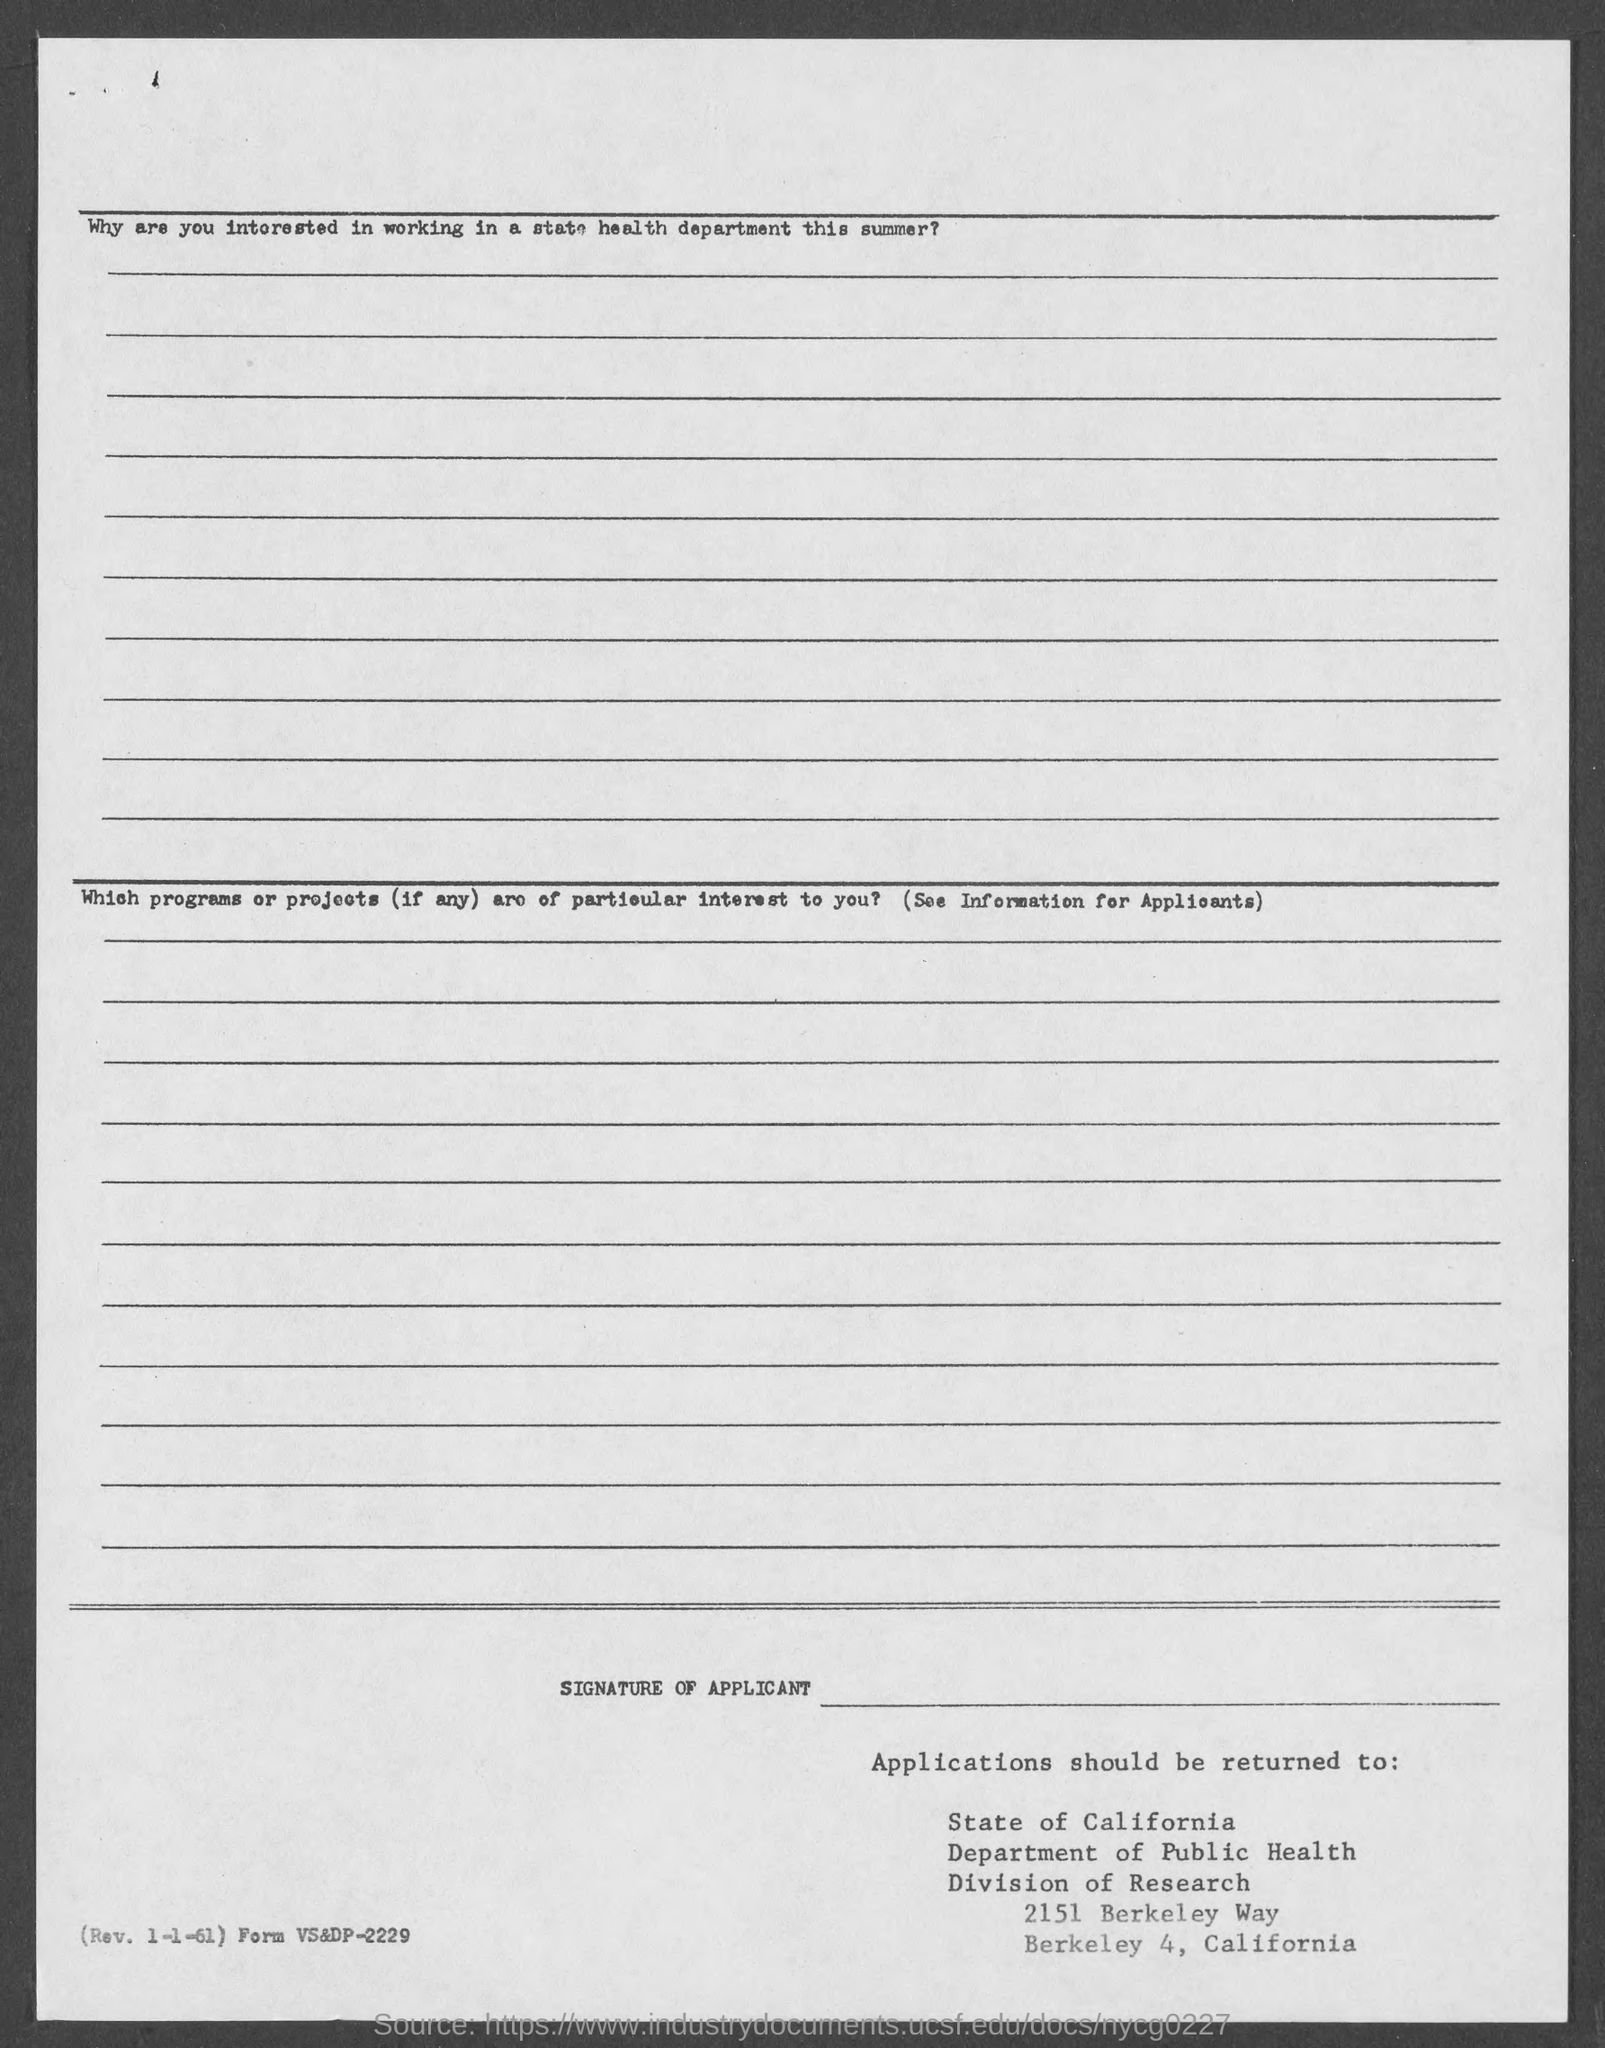Department of public health is in which division?
Provide a succinct answer. Division of Research. 